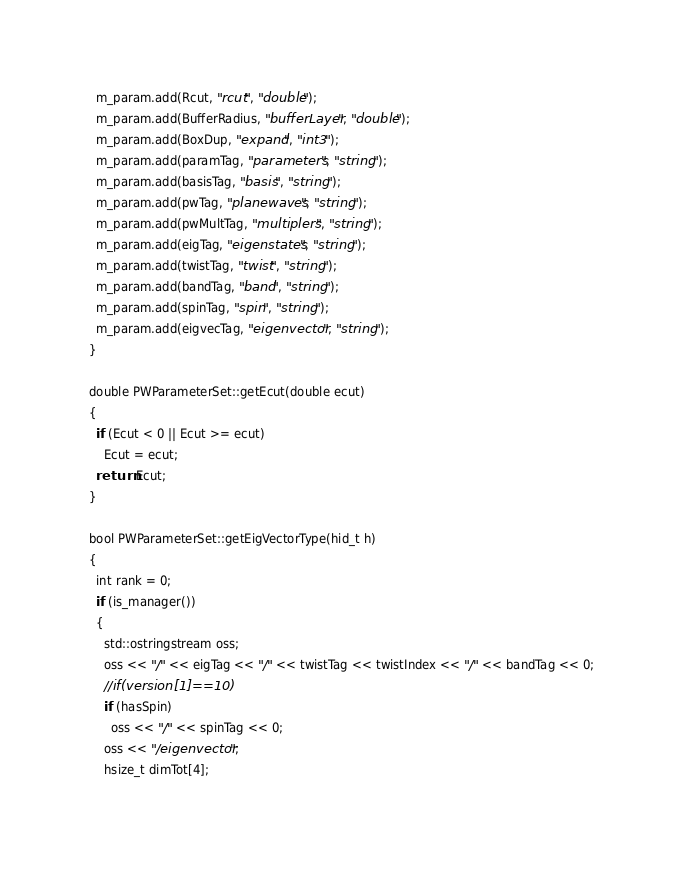Convert code to text. <code><loc_0><loc_0><loc_500><loc_500><_C++_>  m_param.add(Rcut, "rcut", "double");
  m_param.add(BufferRadius, "bufferLayer", "double");
  m_param.add(BoxDup, "expand", "int3");
  m_param.add(paramTag, "parameters", "string");
  m_param.add(basisTag, "basis", "string");
  m_param.add(pwTag, "planewaves", "string");
  m_param.add(pwMultTag, "multiplers", "string");
  m_param.add(eigTag, "eigenstates", "string");
  m_param.add(twistTag, "twist", "string");
  m_param.add(bandTag, "band", "string");
  m_param.add(spinTag, "spin", "string");
  m_param.add(eigvecTag, "eigenvector", "string");
}

double PWParameterSet::getEcut(double ecut)
{
  if (Ecut < 0 || Ecut >= ecut)
    Ecut = ecut;
  return Ecut;
}

bool PWParameterSet::getEigVectorType(hid_t h)
{
  int rank = 0;
  if (is_manager())
  {
    std::ostringstream oss;
    oss << "/" << eigTag << "/" << twistTag << twistIndex << "/" << bandTag << 0;
    //if(version[1]==10)
    if (hasSpin)
      oss << "/" << spinTag << 0;
    oss << "/eigenvector";
    hsize_t dimTot[4];</code> 